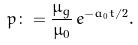<formula> <loc_0><loc_0><loc_500><loc_500>p \colon = \frac { \mu _ { g } } { \mu _ { 0 } } \, e ^ { - a _ { 0 } t / 2 } .</formula> 